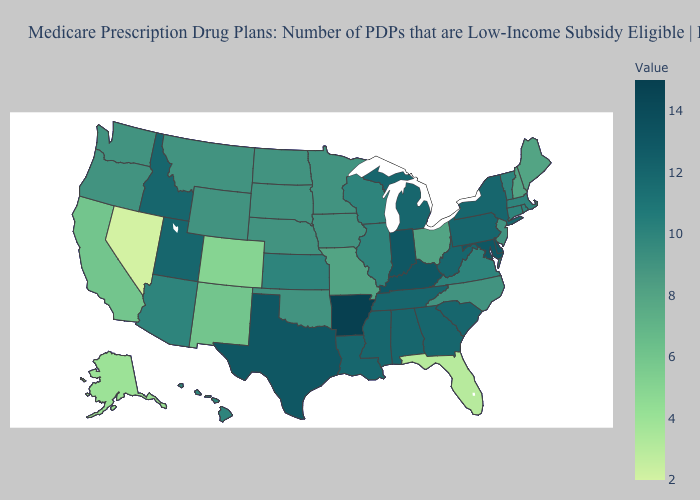Does Virginia have the highest value in the USA?
Write a very short answer. No. Which states have the lowest value in the USA?
Answer briefly. Nevada. Which states have the highest value in the USA?
Keep it brief. Arkansas. Which states hav the highest value in the Northeast?
Answer briefly. New York, Pennsylvania. Which states have the lowest value in the USA?
Quick response, please. Nevada. Among the states that border Georgia , which have the highest value?
Concise answer only. Alabama, South Carolina, Tennessee. Does Arkansas have the highest value in the South?
Quick response, please. Yes. Among the states that border Nevada , which have the lowest value?
Write a very short answer. California. 